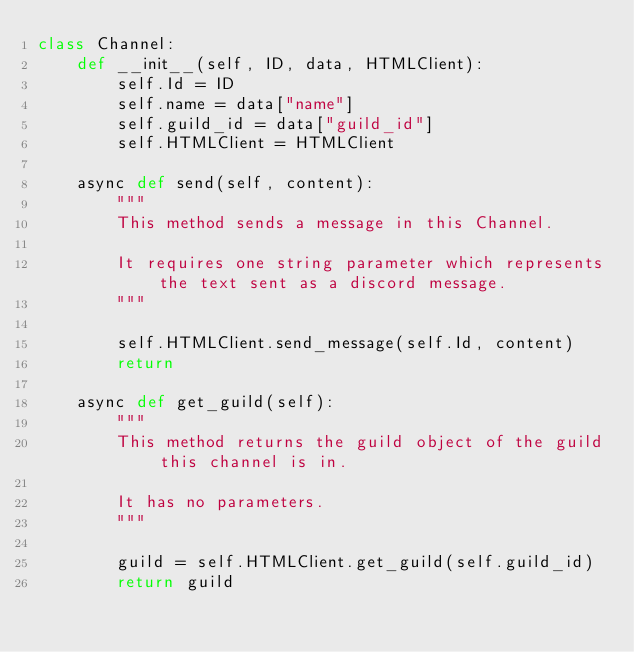Convert code to text. <code><loc_0><loc_0><loc_500><loc_500><_Python_>class Channel:
    def __init__(self, ID, data, HTMLClient):
        self.Id = ID
        self.name = data["name"]
        self.guild_id = data["guild_id"]
        self.HTMLClient = HTMLClient

    async def send(self, content):
        """
        This method sends a message in this Channel.
        
        It requires one string parameter which represents the text sent as a discord message.
        """

        self.HTMLClient.send_message(self.Id, content)
        return

    async def get_guild(self):
        """
        This method returns the guild object of the guild this channel is in.

        It has no parameters.
        """

        guild = self.HTMLClient.get_guild(self.guild_id)
        return guild</code> 